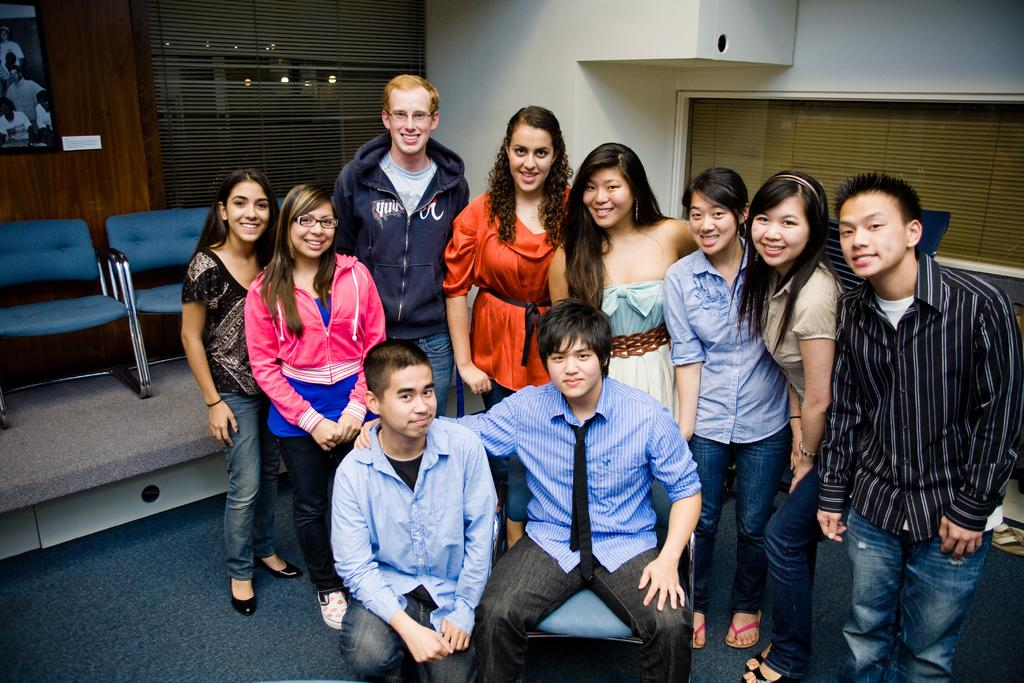Who or what is present in the image? There are people in the image. What is the facial expression of the people in the image? The people are smiling. What can be seen on the left side of the image? There are blue colored chairs and a television on the left side of the image. What type of mine is visible in the image? There is no mine present in the image. Can you describe the park that is featured in the image? There is no park present in the image. 